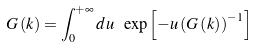<formula> <loc_0><loc_0><loc_500><loc_500>G \left ( { k } \right ) = \int _ { 0 } ^ { + \infty } d u \text { } \exp \left [ - u \left ( G \left ( { k } \right ) \right ) ^ { - 1 } \right ]</formula> 